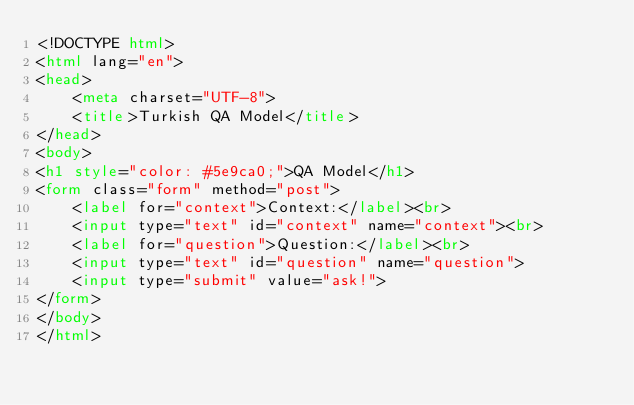<code> <loc_0><loc_0><loc_500><loc_500><_HTML_><!DOCTYPE html>
<html lang="en">
<head>
    <meta charset="UTF-8">
    <title>Turkish QA Model</title>
</head>
<body>
<h1 style="color: #5e9ca0;">QA Model</h1>
<form class="form" method="post">
    <label for="context">Context:</label><br>
    <input type="text" id="context" name="context"><br>
    <label for="question">Question:</label><br>
    <input type="text" id="question" name="question">
    <input type="submit" value="ask!">
</form>
</body>
</html></code> 